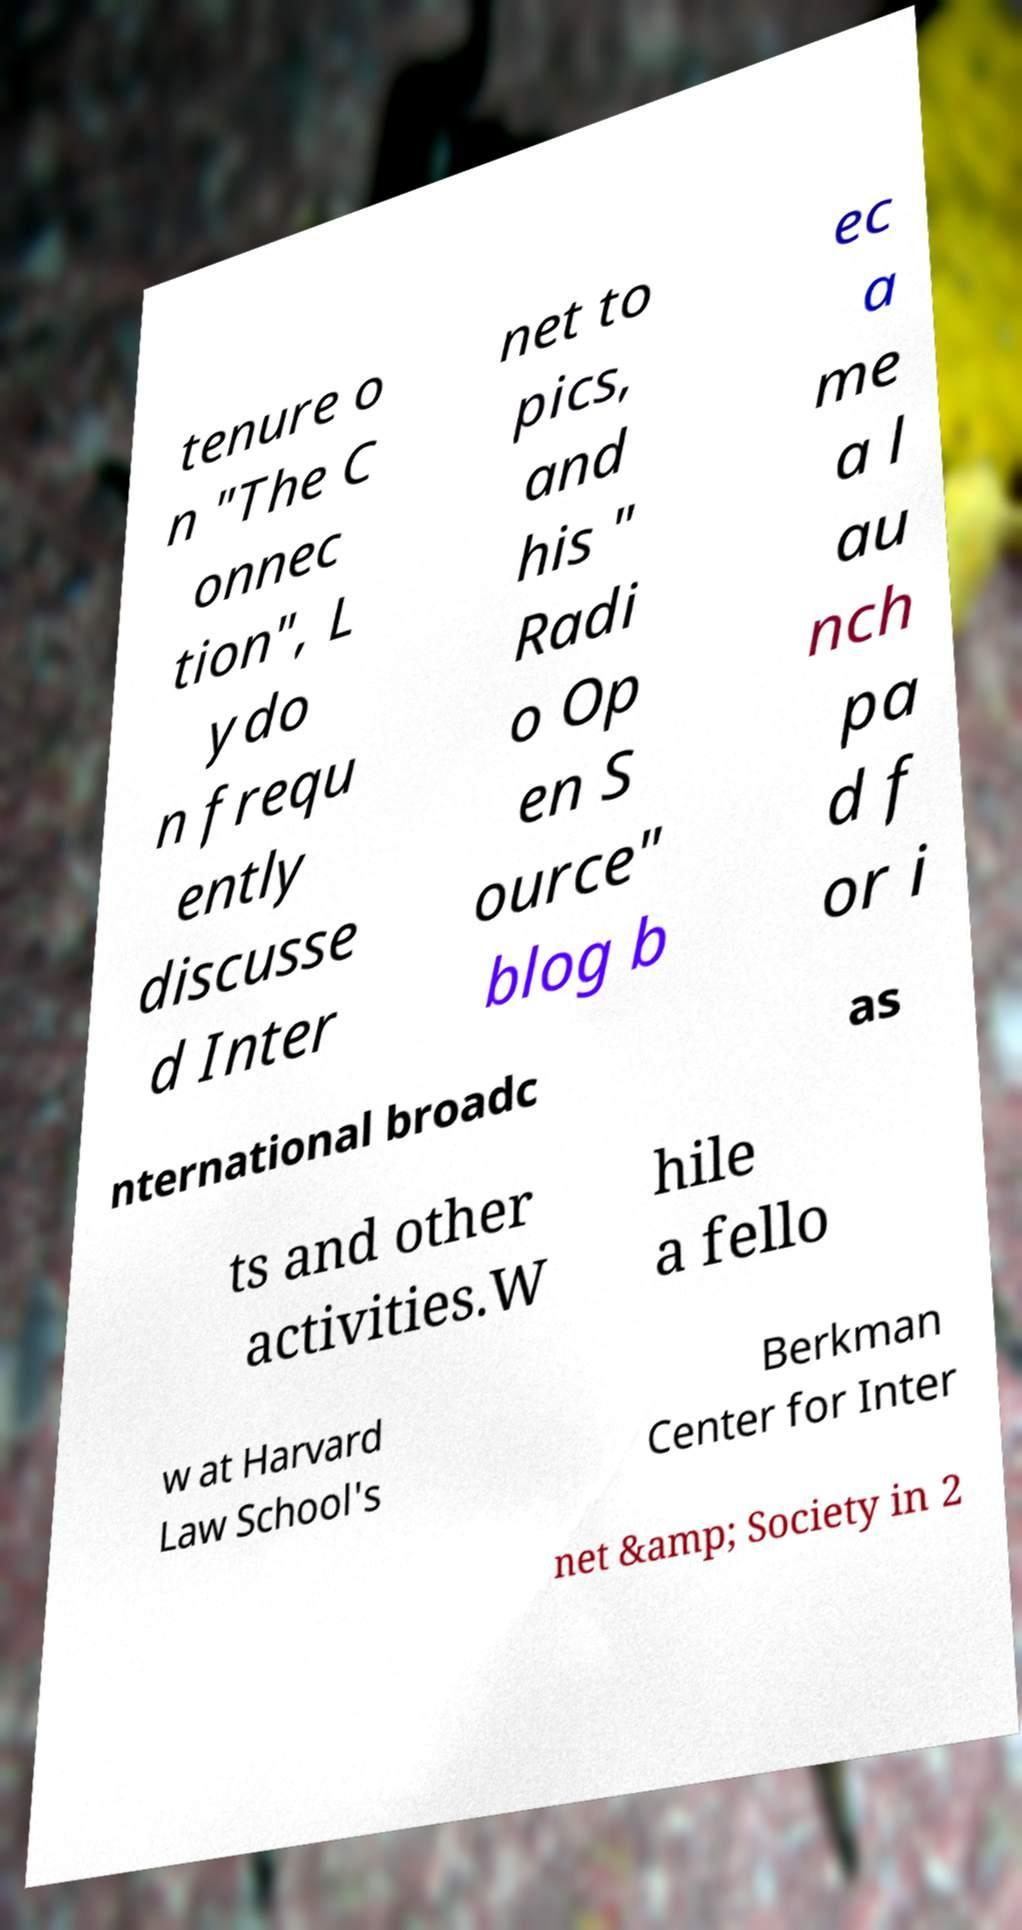I need the written content from this picture converted into text. Can you do that? tenure o n "The C onnec tion", L ydo n frequ ently discusse d Inter net to pics, and his " Radi o Op en S ource" blog b ec a me a l au nch pa d f or i nternational broadc as ts and other activities.W hile a fello w at Harvard Law School's Berkman Center for Inter net &amp; Society in 2 